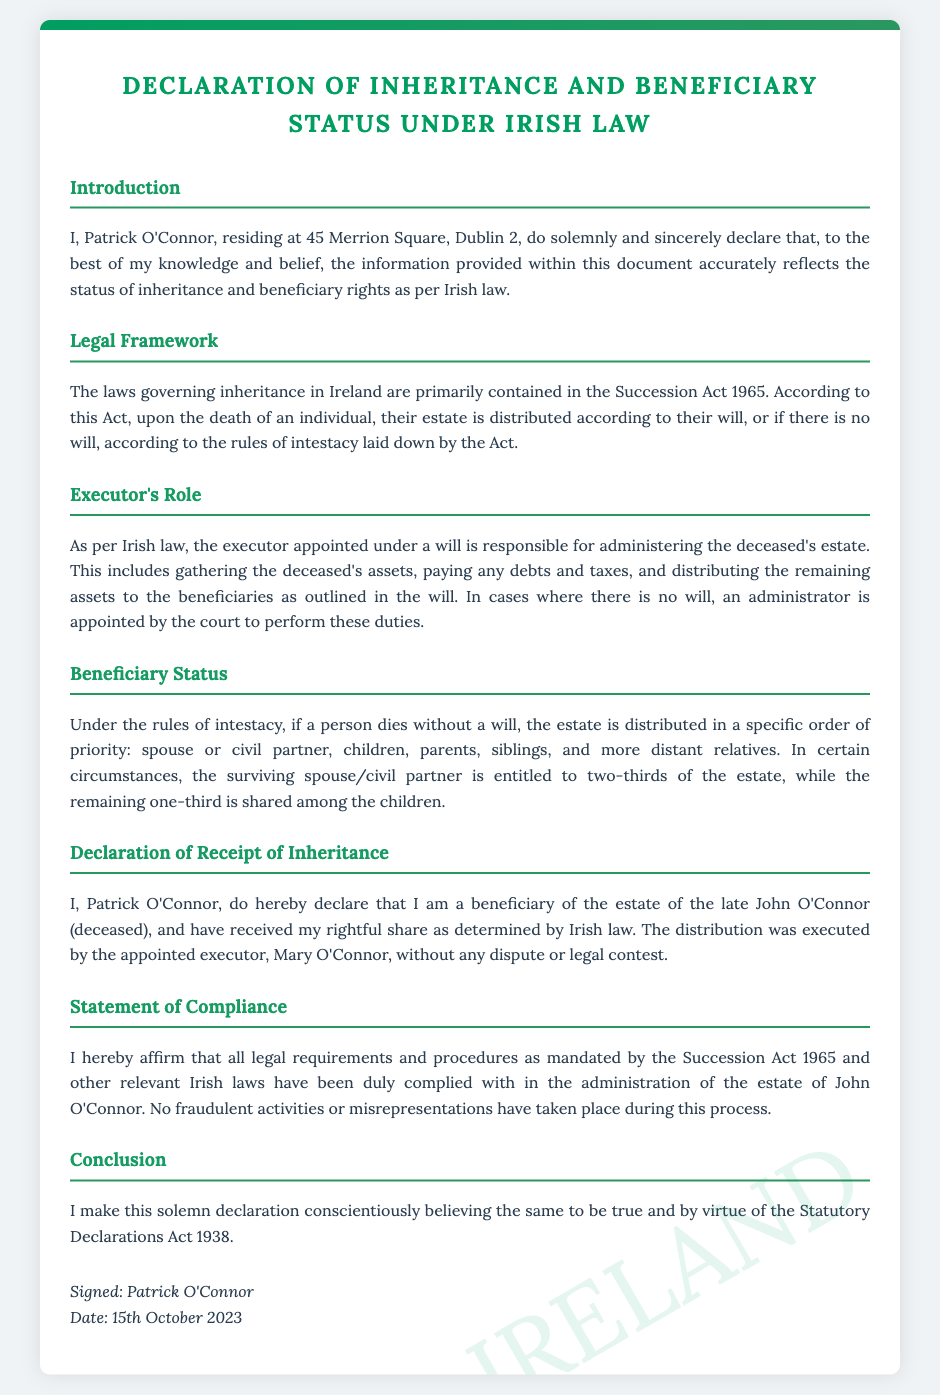What is the name of the declarant? The declarant's name is mentioned at the beginning of the document as "Patrick O'Connor".
Answer: Patrick O'Connor What is the address of the declarant? The document states the declarant's address as "45 Merrion Square, Dublin 2".
Answer: 45 Merrion Square, Dublin 2 What law governs inheritance in Ireland? The document specifies that inheritance laws are primarily contained in "the Succession Act 1965".
Answer: Succession Act 1965 Who is the executor mentioned in the document? The document identifies the executor responsible for the estate as "Mary O'Connor".
Answer: Mary O'Connor What date was the declaration signed? The document shows that the declaration was signed on "15th October 2023".
Answer: 15th October 2023 How much of the estate is the surviving spouse entitled to under intestacy? The document states that the surviving spouse may be entitled to "two-thirds of the estate".
Answer: two-thirds What is the title of the section discussing the role of the executor? The section discussing the role of the executor is titled "Executor's Role".
Answer: Executor's Role What legal act does the declarant affirm compliance with? The declarant affirms compliance with the "Succession Act 1965" in the statement of compliance.
Answer: Succession Act 1965 What type of law is primarily mentioned in relation to inheritance distribution? The document mentions "intestacy" in relation to laws governing inheritance distribution.
Answer: intestacy 